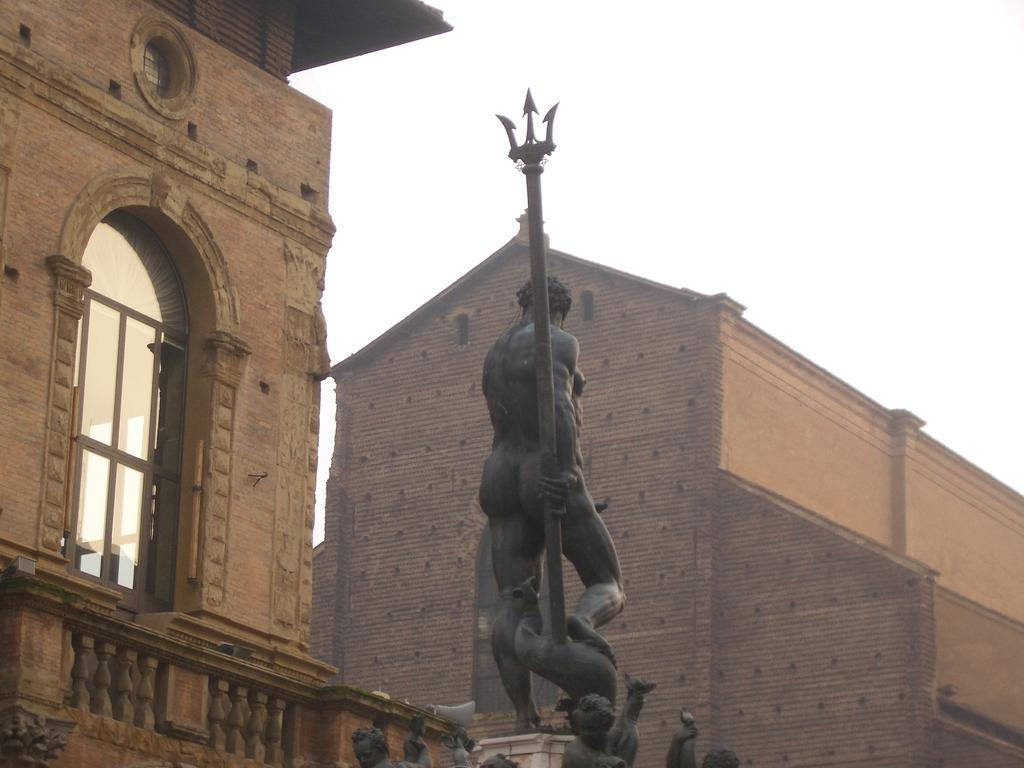What is the main subject in the center of the image? There is a statue in the center of the image. What can be seen in the distance behind the statue? There are buildings in the background of the image. What architectural feature is present in the image? There is a window in the image. What is visible at the top of the image? The sky is visible at the top of the image. How many apples are on the statue in the image? There are no apples present on the statue in the image. What type of alarm is going off in the image? There is no alarm present in the image. 